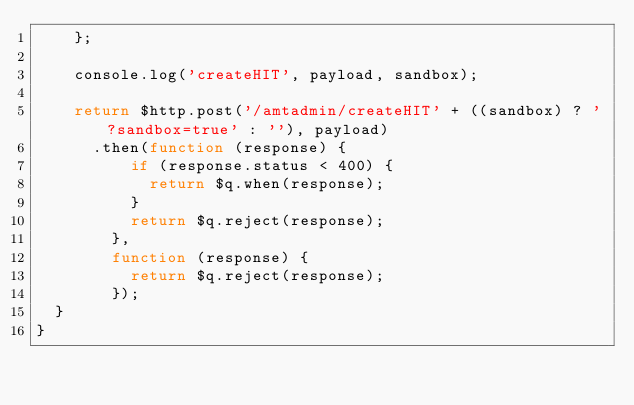Convert code to text. <code><loc_0><loc_0><loc_500><loc_500><_JavaScript_>    };

    console.log('createHIT', payload, sandbox);

    return $http.post('/amtadmin/createHIT' + ((sandbox) ? '?sandbox=true' : ''), payload)
      .then(function (response) {
          if (response.status < 400) {
            return $q.when(response);
          }
          return $q.reject(response);
        },
        function (response) {
          return $q.reject(response);
        });
  }
}
</code> 